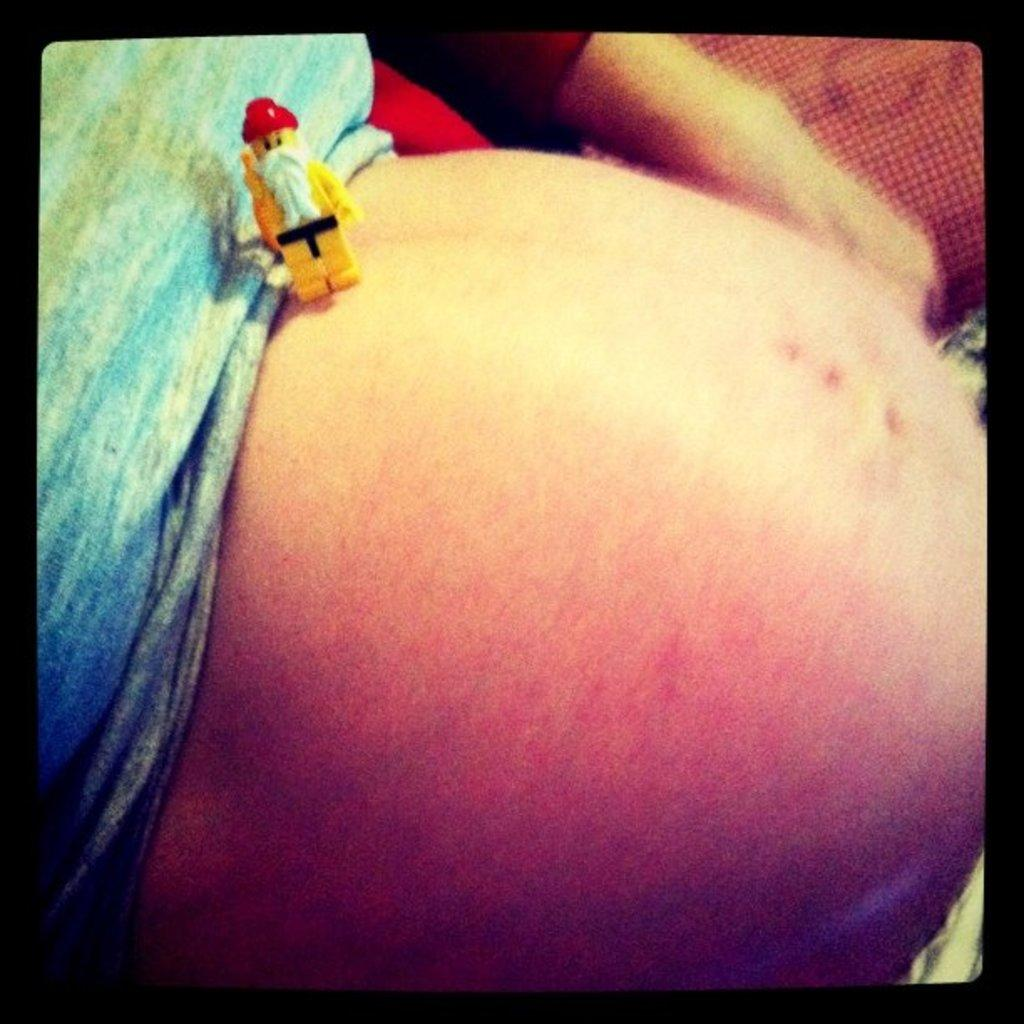What is on the belly of the person in the foreground of the image? There is a toy on the belly of the person in the foreground of the image. What can be seen on the left side of the image? There is a T-shirt on the left side of the image. What type of verse is being recited by the person in the image? There is no indication in the image that a verse is being recited, as the focus is on the toy on the person's belly and the T-shirt on the left side of the image. 